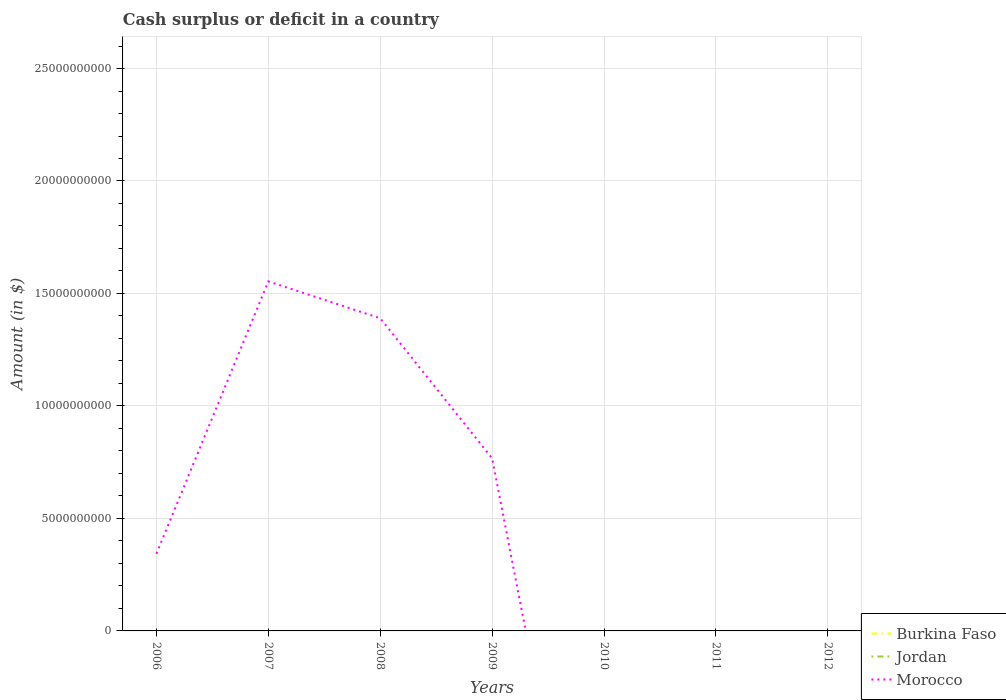How many different coloured lines are there?
Your response must be concise. 1. Does the line corresponding to Morocco intersect with the line corresponding to Burkina Faso?
Make the answer very short. No. Is the number of lines equal to the number of legend labels?
Your answer should be compact. No. What is the difference between the highest and the second highest amount of cash surplus or deficit in Morocco?
Your answer should be compact. 1.55e+1. How many years are there in the graph?
Provide a succinct answer. 7. Are the values on the major ticks of Y-axis written in scientific E-notation?
Give a very brief answer. No. Does the graph contain any zero values?
Offer a very short reply. Yes. Does the graph contain grids?
Your answer should be compact. Yes. How many legend labels are there?
Give a very brief answer. 3. How are the legend labels stacked?
Your response must be concise. Vertical. What is the title of the graph?
Offer a very short reply. Cash surplus or deficit in a country. What is the label or title of the Y-axis?
Ensure brevity in your answer.  Amount (in $). What is the Amount (in $) in Burkina Faso in 2006?
Your answer should be very brief. 0. What is the Amount (in $) of Morocco in 2006?
Offer a terse response. 3.43e+09. What is the Amount (in $) of Burkina Faso in 2007?
Your response must be concise. 0. What is the Amount (in $) of Jordan in 2007?
Ensure brevity in your answer.  0. What is the Amount (in $) in Morocco in 2007?
Provide a succinct answer. 1.55e+1. What is the Amount (in $) of Burkina Faso in 2008?
Make the answer very short. 0. What is the Amount (in $) in Jordan in 2008?
Offer a very short reply. 0. What is the Amount (in $) of Morocco in 2008?
Your answer should be compact. 1.39e+1. What is the Amount (in $) in Burkina Faso in 2009?
Provide a short and direct response. 0. What is the Amount (in $) in Morocco in 2009?
Make the answer very short. 7.67e+09. What is the Amount (in $) in Burkina Faso in 2010?
Offer a very short reply. 0. What is the Amount (in $) in Morocco in 2010?
Provide a short and direct response. 0. What is the Amount (in $) of Jordan in 2011?
Provide a succinct answer. 0. What is the Amount (in $) of Morocco in 2011?
Your answer should be very brief. 0. What is the Amount (in $) in Burkina Faso in 2012?
Your response must be concise. 0. Across all years, what is the maximum Amount (in $) in Morocco?
Your answer should be compact. 1.55e+1. What is the total Amount (in $) in Jordan in the graph?
Offer a terse response. 0. What is the total Amount (in $) of Morocco in the graph?
Make the answer very short. 4.05e+1. What is the difference between the Amount (in $) of Morocco in 2006 and that in 2007?
Provide a short and direct response. -1.21e+1. What is the difference between the Amount (in $) in Morocco in 2006 and that in 2008?
Provide a succinct answer. -1.05e+1. What is the difference between the Amount (in $) in Morocco in 2006 and that in 2009?
Keep it short and to the point. -4.24e+09. What is the difference between the Amount (in $) of Morocco in 2007 and that in 2008?
Make the answer very short. 1.64e+09. What is the difference between the Amount (in $) in Morocco in 2007 and that in 2009?
Keep it short and to the point. 7.87e+09. What is the difference between the Amount (in $) in Morocco in 2008 and that in 2009?
Keep it short and to the point. 6.23e+09. What is the average Amount (in $) of Morocco per year?
Your response must be concise. 5.79e+09. What is the ratio of the Amount (in $) in Morocco in 2006 to that in 2007?
Offer a terse response. 0.22. What is the ratio of the Amount (in $) of Morocco in 2006 to that in 2008?
Give a very brief answer. 0.25. What is the ratio of the Amount (in $) in Morocco in 2006 to that in 2009?
Offer a very short reply. 0.45. What is the ratio of the Amount (in $) of Morocco in 2007 to that in 2008?
Provide a succinct answer. 1.12. What is the ratio of the Amount (in $) of Morocco in 2007 to that in 2009?
Keep it short and to the point. 2.03. What is the ratio of the Amount (in $) in Morocco in 2008 to that in 2009?
Offer a terse response. 1.81. What is the difference between the highest and the second highest Amount (in $) in Morocco?
Provide a succinct answer. 1.64e+09. What is the difference between the highest and the lowest Amount (in $) of Morocco?
Your answer should be compact. 1.55e+1. 